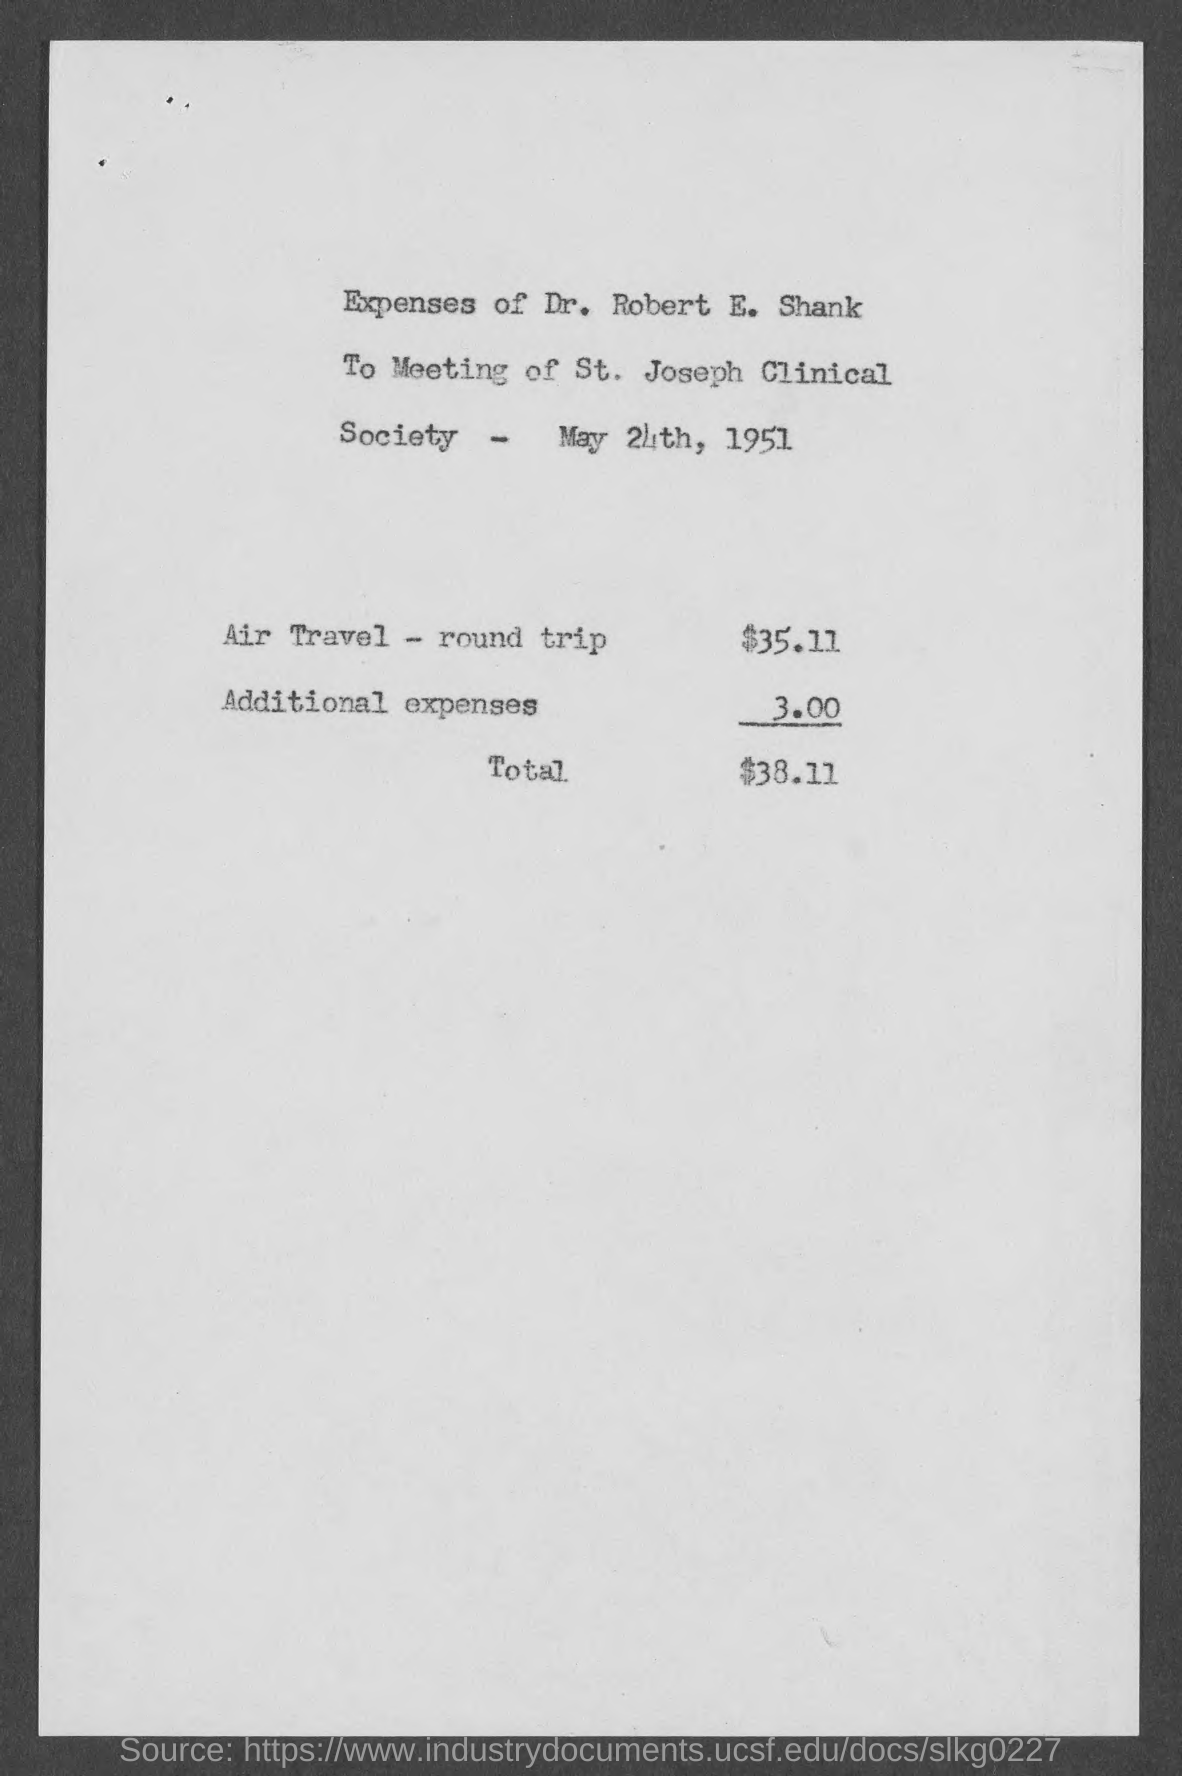What is the total amount ?
Your answer should be compact. $38.11. What is the amount of additional expenses ?
Your answer should be very brief. 3.00. What is the expense for air travel- round trip?
Give a very brief answer. $35.11. Whose expenses are given in the page ?
Provide a succinct answer. Dr. Robert E. Shank. 